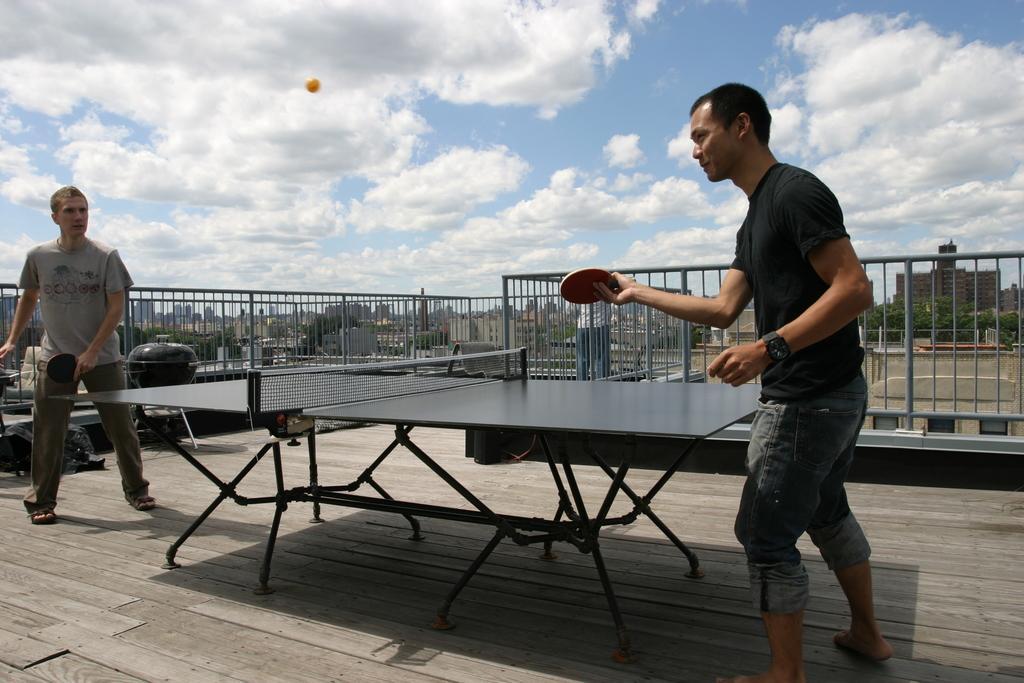How would you summarize this image in a sentence or two? The image is taken in the outdoor. There are two people who are playing table tennis in the image. They are holding bats in their hands. In the center there is a table. In the background there is a fence, buildings and a sky. 